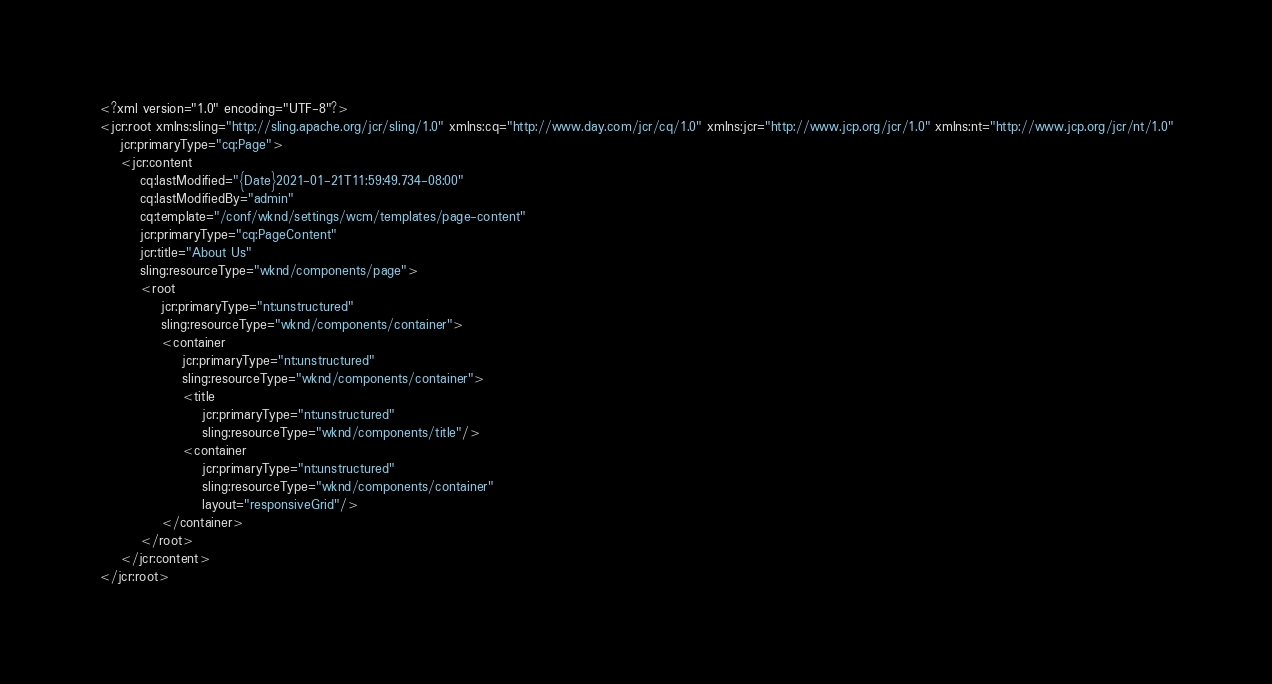Convert code to text. <code><loc_0><loc_0><loc_500><loc_500><_XML_><?xml version="1.0" encoding="UTF-8"?>
<jcr:root xmlns:sling="http://sling.apache.org/jcr/sling/1.0" xmlns:cq="http://www.day.com/jcr/cq/1.0" xmlns:jcr="http://www.jcp.org/jcr/1.0" xmlns:nt="http://www.jcp.org/jcr/nt/1.0"
    jcr:primaryType="cq:Page">
    <jcr:content
        cq:lastModified="{Date}2021-01-21T11:59:49.734-08:00"
        cq:lastModifiedBy="admin"
        cq:template="/conf/wknd/settings/wcm/templates/page-content"
        jcr:primaryType="cq:PageContent"
        jcr:title="About Us"
        sling:resourceType="wknd/components/page">
        <root
            jcr:primaryType="nt:unstructured"
            sling:resourceType="wknd/components/container">
            <container
                jcr:primaryType="nt:unstructured"
                sling:resourceType="wknd/components/container">
                <title
                    jcr:primaryType="nt:unstructured"
                    sling:resourceType="wknd/components/title"/>
                <container
                    jcr:primaryType="nt:unstructured"
                    sling:resourceType="wknd/components/container"
                    layout="responsiveGrid"/>
            </container>
        </root>
    </jcr:content>
</jcr:root>
</code> 